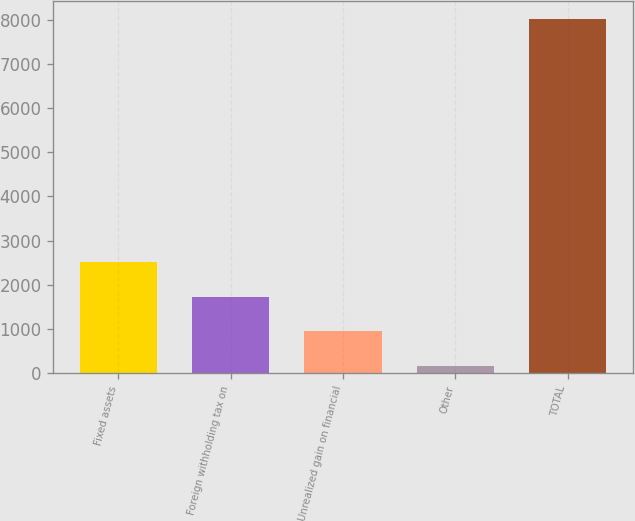<chart> <loc_0><loc_0><loc_500><loc_500><bar_chart><fcel>Fixed assets<fcel>Foreign withholding tax on<fcel>Unrealized gain on financial<fcel>Other<fcel>TOTAL<nl><fcel>2518.1<fcel>1732.4<fcel>946.7<fcel>161<fcel>8018<nl></chart> 